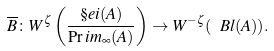Convert formula to latex. <formula><loc_0><loc_0><loc_500><loc_500>\overline { B } \colon W ^ { \zeta } \left ( \frac { \S e i ( A ) } { \Pr i m _ { \infty } ( A ) } \right ) \to W ^ { - \zeta } ( \ B l ( A ) ) .</formula> 